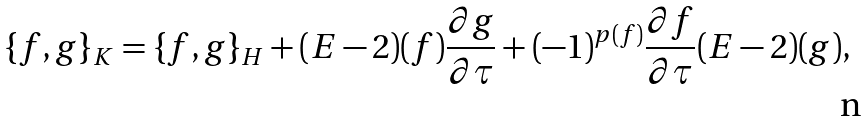<formula> <loc_0><loc_0><loc_500><loc_500>\{ f , g \} _ { K } = \{ f , g \} _ { H } + ( E - 2 ) ( f ) \frac { \partial g } { \partial \tau } + ( - 1 ) ^ { p ( f ) } \frac { \partial f } { \partial \tau } ( E - 2 ) ( g ) ,</formula> 